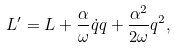<formula> <loc_0><loc_0><loc_500><loc_500>L ^ { \prime } = L + \frac { \alpha } { \omega } \dot { q } q + \frac { \alpha ^ { 2 } } { 2 \omega } q ^ { 2 } ,</formula> 